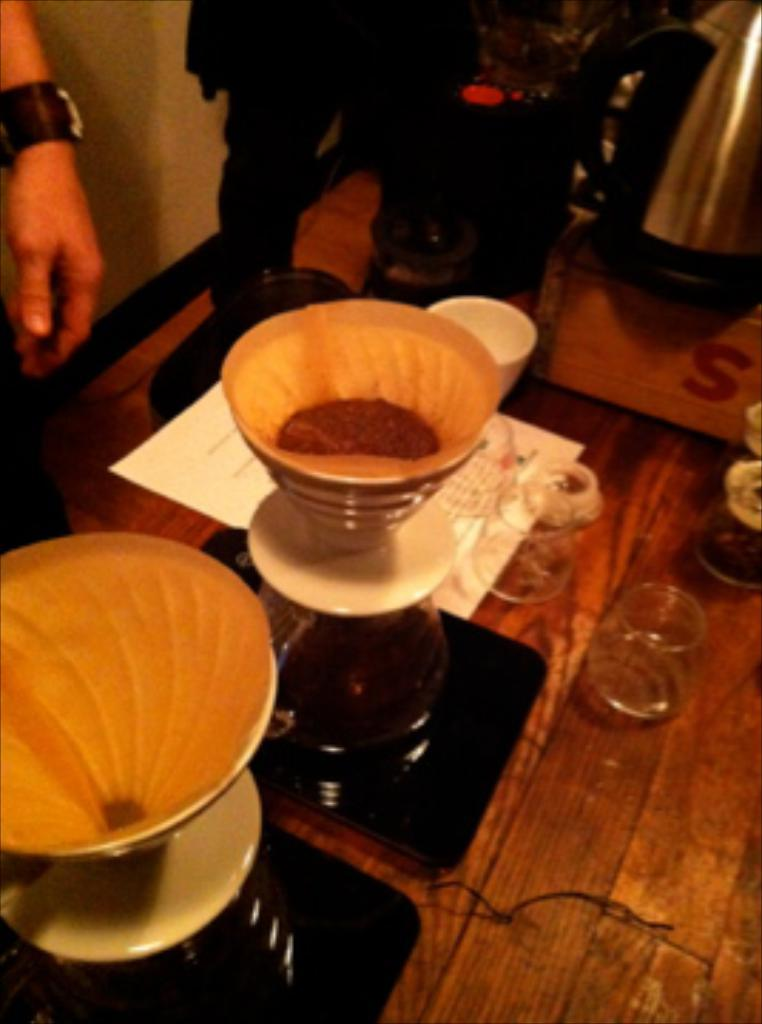What is the main piece of furniture in the image? There is a table in the image. What type of objects can be seen on the table? There are flasks, a funnel, glasses, paper, and other objects on the table. Can you describe the people in the background of the image? There is no specific description of the people in the background, but they are present. What is visible in the background of the image besides the people? There is a wall in the background of the image. What is the price of the seed that is being used in the image? There is no seed present in the image, so it is not possible to determine its price. Can you describe the swimming technique of the people in the background of the image? There is no indication of swimming or any water-related activity in the image, so it is not possible to describe any swimming technique. 